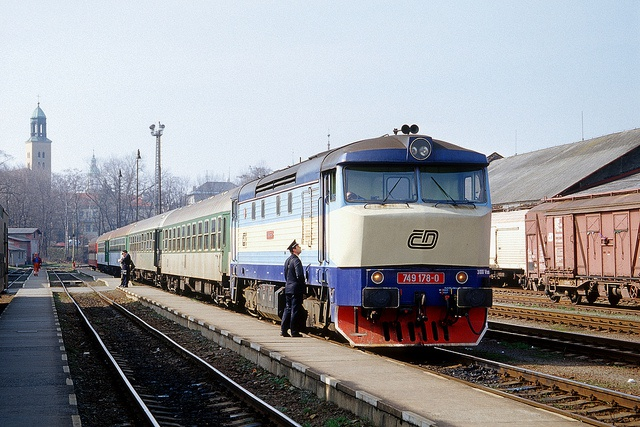Describe the objects in this image and their specific colors. I can see train in white, black, lightgray, darkgray, and gray tones, train in lavender, tan, black, gray, and darkgray tones, people in white, black, and gray tones, people in white, black, gray, and darkgray tones, and people in white, black, maroon, navy, and gray tones in this image. 